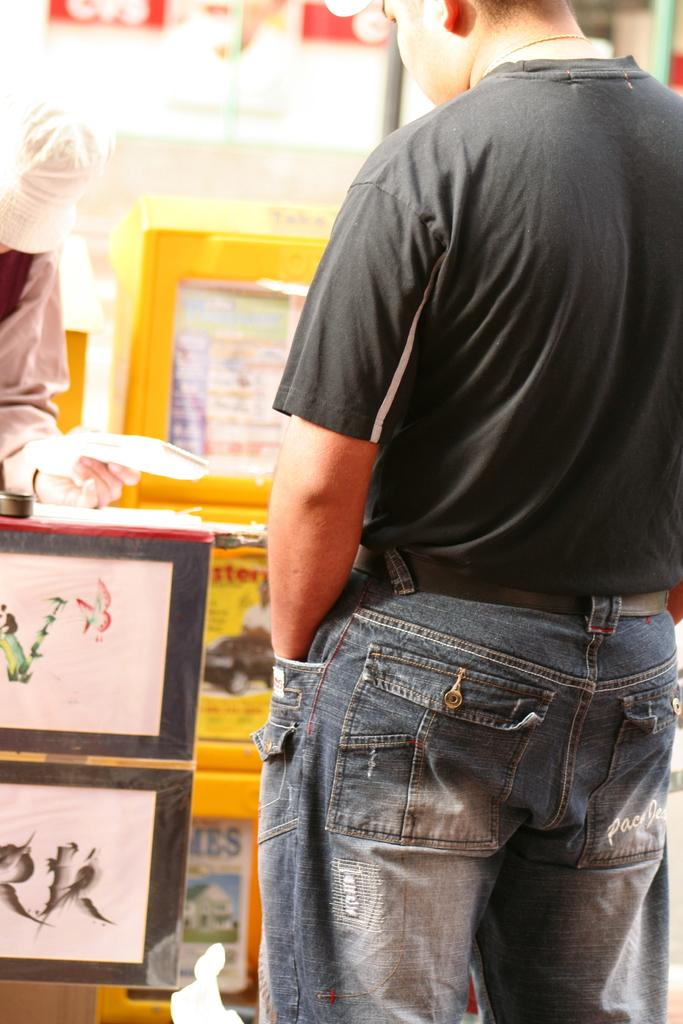How many people are present in the image? There are two people in the image. What can be seen in the background of the image? There is a wall in the image. What type of decorative items are visible in the image? There are photo frames in the image. Can you describe any other objects in the image? There are unspecified objects in the image. What type of animals can be seen at the zoo in the image? There is no zoo present in the image, so it is not possible to determine what animals might be seen there. 